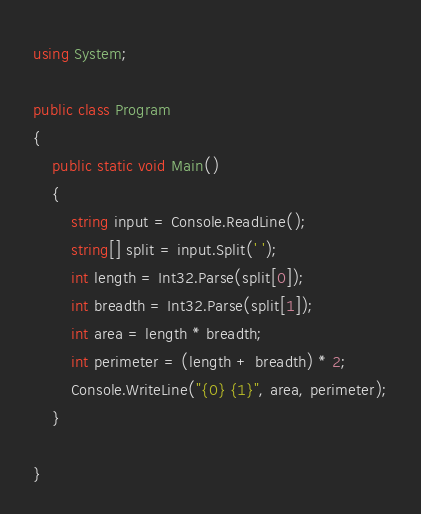Convert code to text. <code><loc_0><loc_0><loc_500><loc_500><_C#_>using System;

public class Program
{
    public static void Main()
    {
        string input = Console.ReadLine();
        string[] split = input.Split(' ');
        int length = Int32.Parse(split[0]);
        int breadth = Int32.Parse(split[1]);
        int area = length * breadth;
        int perimeter = (length + breadth) * 2;
        Console.WriteLine("{0} {1}", area, perimeter);
    }
    
}
</code> 